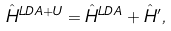<formula> <loc_0><loc_0><loc_500><loc_500>\hat { H } ^ { L D A + U } = \hat { H } ^ { L D A } + \hat { H } ^ { \prime } ,</formula> 